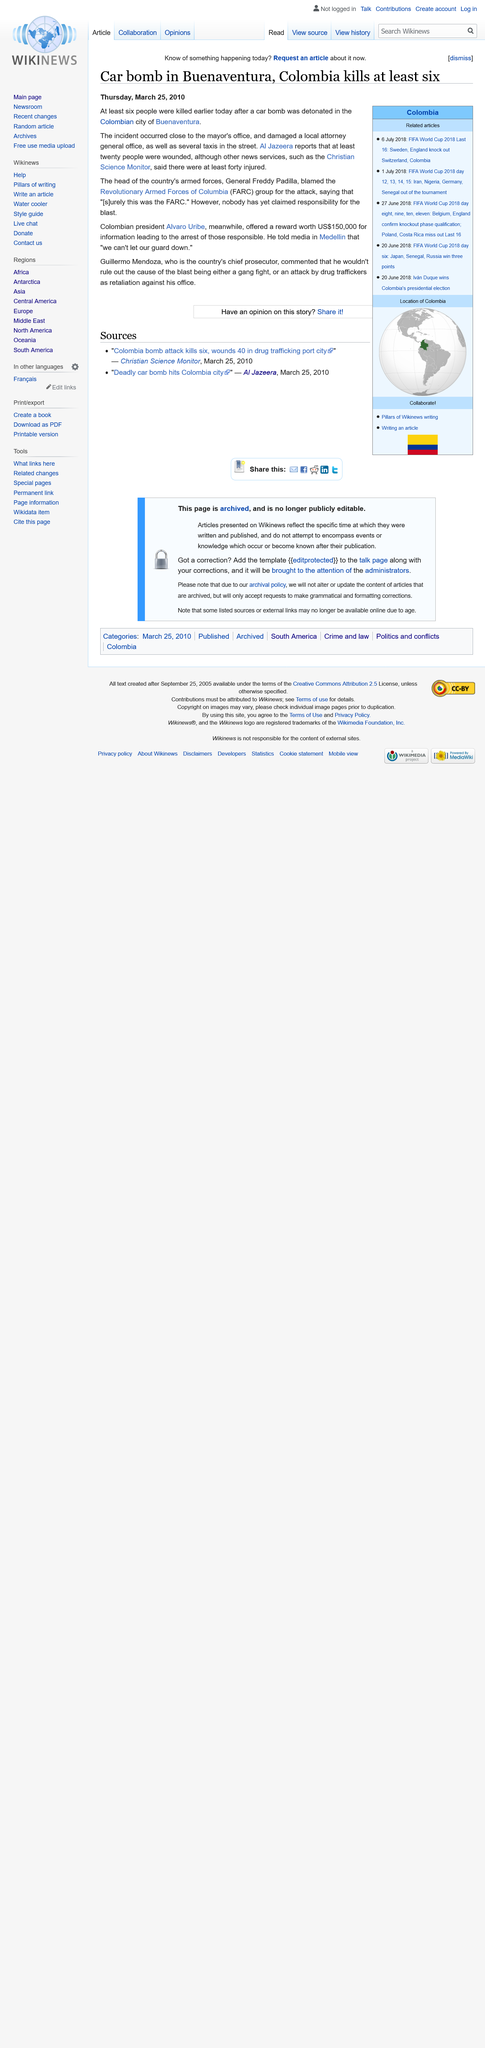Draw attention to some important aspects in this diagram. The Revolutionary Armed Forces of Colombia, commonly known as the FARC, are a group of armed revolutionaries in Colombia who have been engaged in a long-standing conflict with the government. Located in Colombia, Buenaventura is the country's largest and most important port. General Freddy Padilla was the head of the Colombian armed forces and a well-respected military leader. 